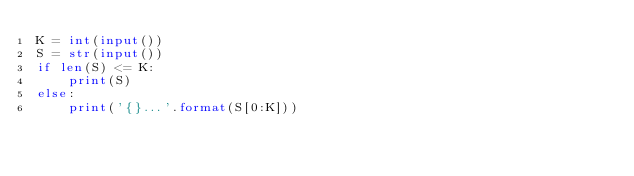<code> <loc_0><loc_0><loc_500><loc_500><_Python_>K = int(input())
S = str(input())
if len(S) <= K:
    print(S)
else:
    print('{}...'.format(S[0:K]))</code> 